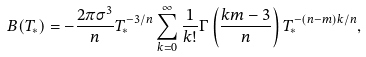Convert formula to latex. <formula><loc_0><loc_0><loc_500><loc_500>B ( T _ { * } ) = - \frac { 2 \pi \sigma ^ { 3 } } { n } T _ { * } ^ { - 3 / n } \sum _ { k = 0 } ^ { \infty } \frac { 1 } { k ! } \Gamma \left ( \frac { k m - 3 } { n } \right ) T _ { * } ^ { - ( n - m ) k / n } ,</formula> 